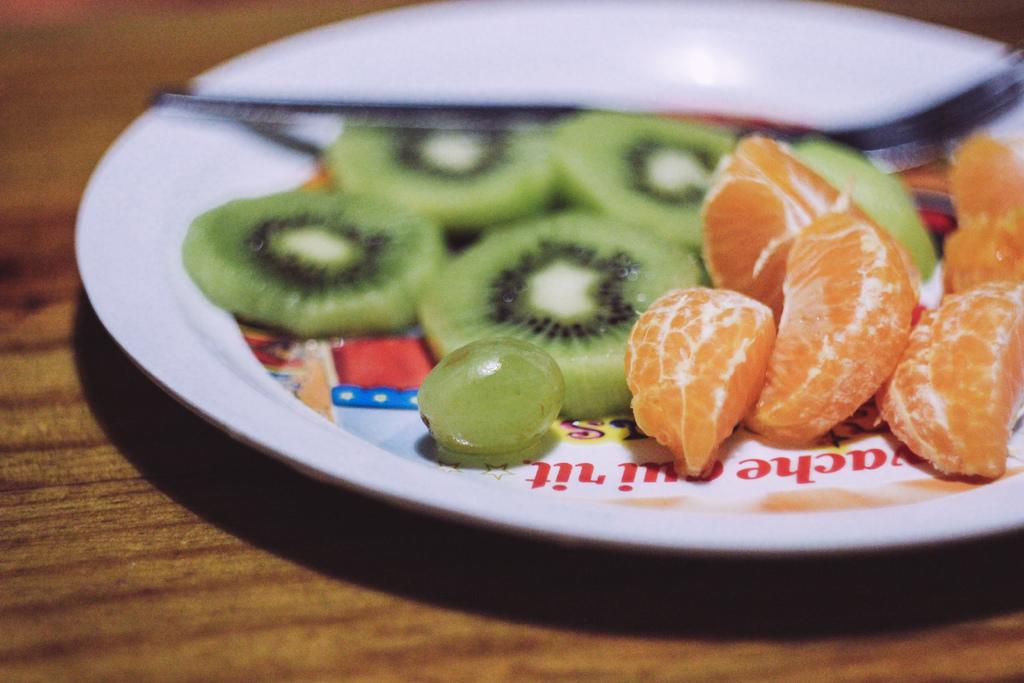What is on the white plate in the image? The plate contains grapes, chopped kiwi, and orange pieces. What color is the plate in the image? The plate is white. Where is the plate placed in the image? The plate is placed on a brown table. What type of whip is being used to prepare the fruit on the plate? There is no whip present in the image, and the fruit is already prepared and placed on the plate. 